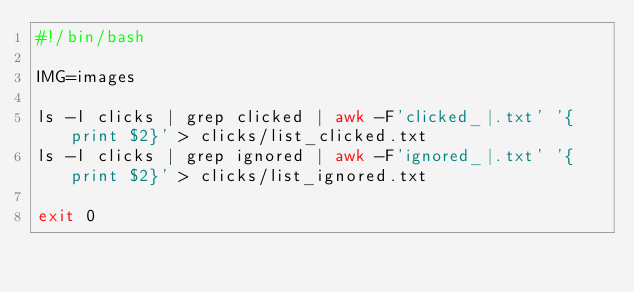Convert code to text. <code><loc_0><loc_0><loc_500><loc_500><_Bash_>#!/bin/bash

IMG=images

ls -l clicks | grep clicked | awk -F'clicked_|.txt' '{print $2}' > clicks/list_clicked.txt
ls -l clicks | grep ignored | awk -F'ignored_|.txt' '{print $2}' > clicks/list_ignored.txt

exit 0
</code> 